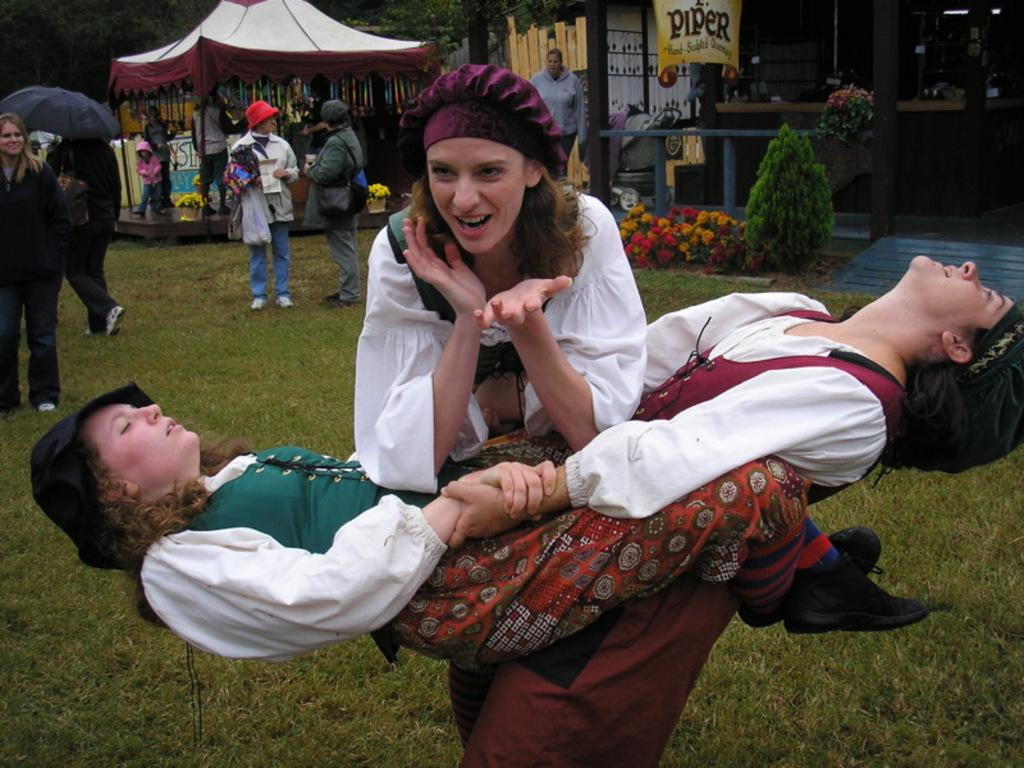How many women are wearing caps in the image? There are three women wearing caps in the image. What is the facial expression of one of the women? One of the women is smiling. What can be seen in the background of the image? In the background of the image, there is grass, people, plants, a stall, pillars, a banner, trees, and other objects. What type of art can be seen on the scarecrow in the image? There is no scarecrow present in the image. How many fish are visible in the image? There are no fish visible in the image. 